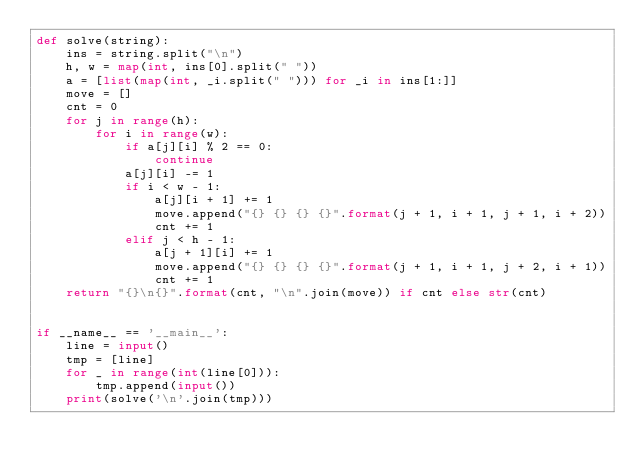<code> <loc_0><loc_0><loc_500><loc_500><_Python_>def solve(string):
    ins = string.split("\n")
    h, w = map(int, ins[0].split(" "))
    a = [list(map(int, _i.split(" "))) for _i in ins[1:]]
    move = []
    cnt = 0
    for j in range(h):
        for i in range(w):
            if a[j][i] % 2 == 0:
                continue
            a[j][i] -= 1
            if i < w - 1:
                a[j][i + 1] += 1
                move.append("{} {} {} {}".format(j + 1, i + 1, j + 1, i + 2))
                cnt += 1
            elif j < h - 1:
                a[j + 1][i] += 1
                move.append("{} {} {} {}".format(j + 1, i + 1, j + 2, i + 1))
                cnt += 1
    return "{}\n{}".format(cnt, "\n".join(move)) if cnt else str(cnt)


if __name__ == '__main__':
    line = input()
    tmp = [line]
    for _ in range(int(line[0])):
        tmp.append(input())
    print(solve('\n'.join(tmp)))
</code> 